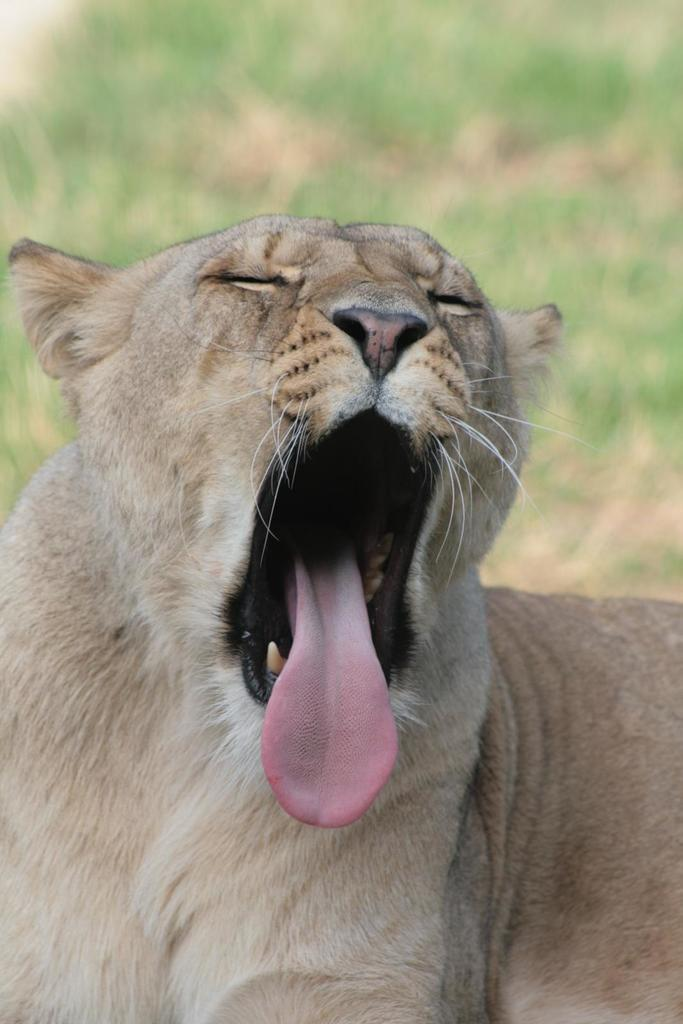What type of animal is in the image? There is a lioness in the image. What is the lioness doing in the image? The lioness is yawning with her mouth open. What part of the lioness' mouth can be seen? The lioness' tongue is visible. Can you describe the background of the image? The background of the image is blurred. What type of umbrella is the lioness holding in the image? There is no umbrella present in the image; the lioness is not holding anything. What is the texture of the lioness' flesh in the image? There is no mention of the lioness' flesh in the provided facts, and it is not possible to determine the texture of her flesh from the image. 